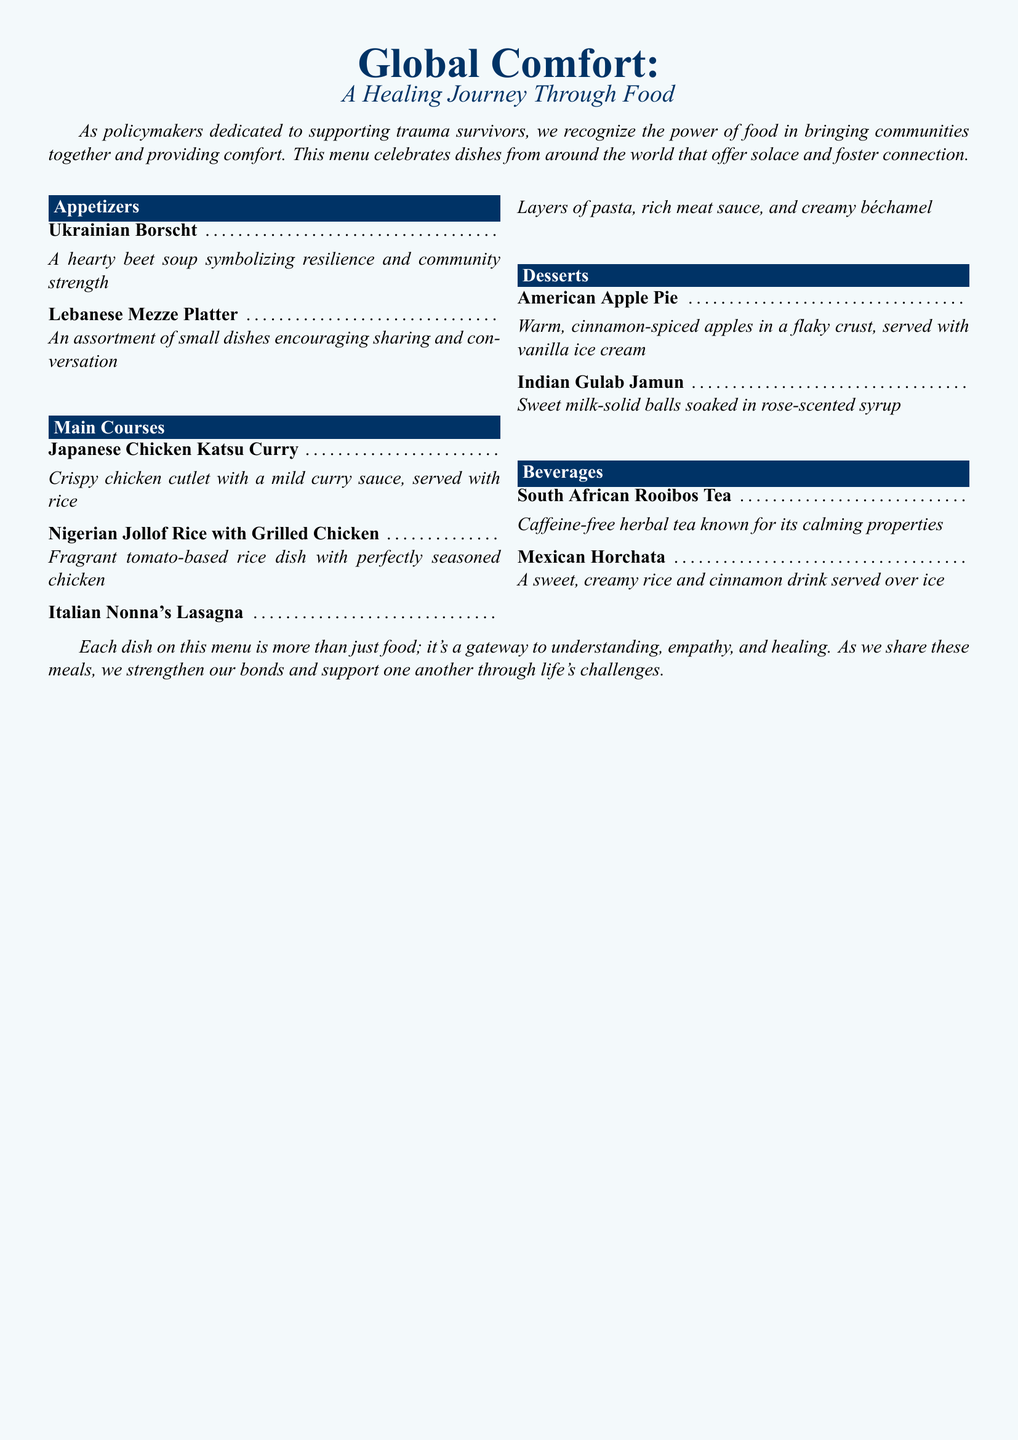What is the theme of the menu? The theme of the menu is centered around global comfort foods, emphasizing community and support through shared meals.
Answer: Global Comfort How many main course options are available? The menu includes three distinct main course options listed under that section.
Answer: Three What dish represents Nigerian cuisine? The dish that represents Nigerian cuisine on the menu is identified clearly in the main courses.
Answer: Jollof Rice with Grilled Chicken Which dessert is made from milk solids? The menu specifies a dessert that contains milk solids, indicating its cultural origin.
Answer: Gulab Jamun What type of tea is featured in the beverage section? The beverage section lists a calming herbal tea known for its unique properties.
Answer: Rooibos Tea What is the cultural significance of the Lebanese Mezze Platter? The platter encourages sharing and conversation, highlighting its role in fostering connections within community settings.
Answer: Sharing and conversation How many appetizers are listed in total? The number of appetizers is determined by counting the options listed in that section.
Answer: Two What is the primary flavor profile of the Japanese Chicken Katsu Curry? The menu describes a specific taste characteristic associated with this dish's sauce.
Answer: Mild curry sauce What is served with the American Apple Pie? The menu indicates a popular pairing that enhances the dessert experience.
Answer: Vanilla ice cream 